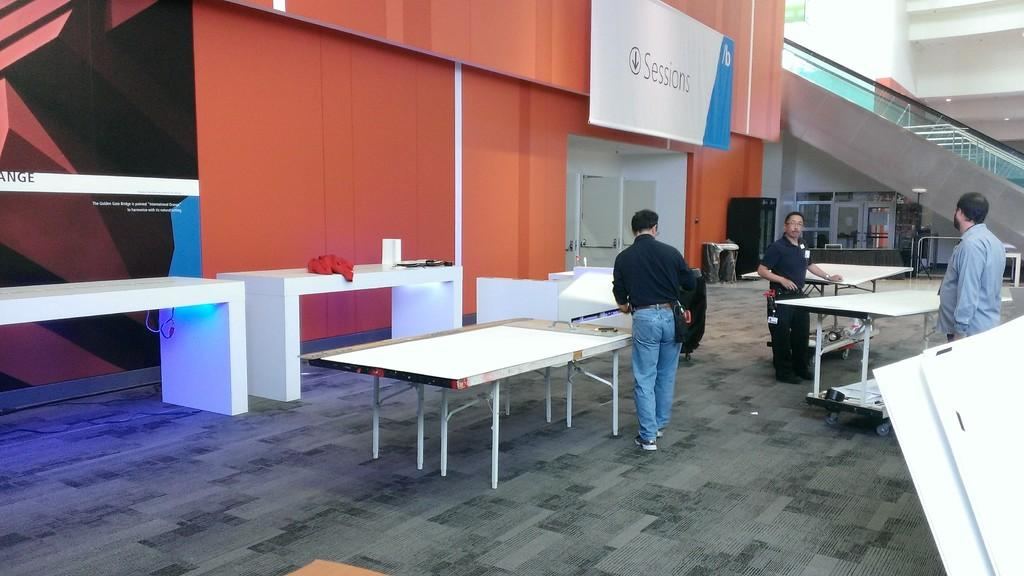How many people are in the image? There are three men in the image. What activity might the men be engaged in, based on the presence of table tennis tables? The men might be playing table tennis, as there are three table tennis tables in the image. What type of boat can be seen in the image? There is no boat present in the image; it features three men and three table tennis tables. What news headline is related to the pickle in the image? There is no pickle or news headline mentioned in the image. 